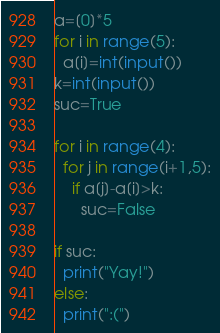<code> <loc_0><loc_0><loc_500><loc_500><_Python_>a=[0]*5
for i in range(5):
  a[i]=int(input())
k=int(input())
suc=True

for i in range(4):
  for j in range(i+1,5):
    if a[j]-a[i]>k:
      suc=False
      
if suc:
  print("Yay!")
else:
  print(":(")
</code> 